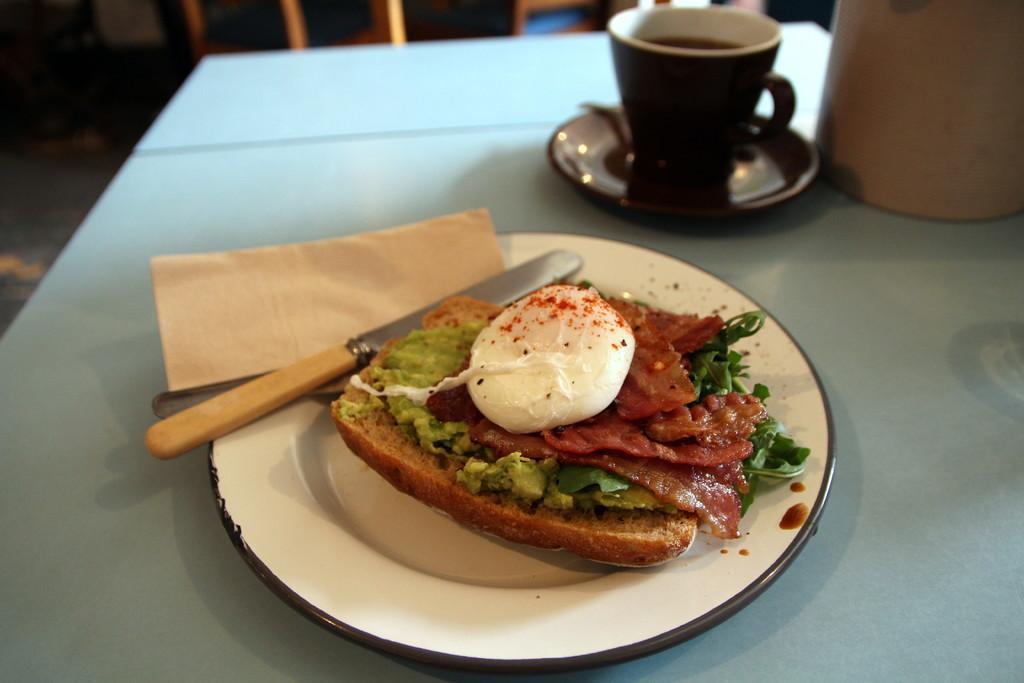Describe this image in one or two sentences. This image consist of a table. covered with a blue. On which a plate of food is kept, along with knife and tissue, To the right, there is a cup of coffee and saucer. At the bottom, there is floor. In the front, there are chairs. 